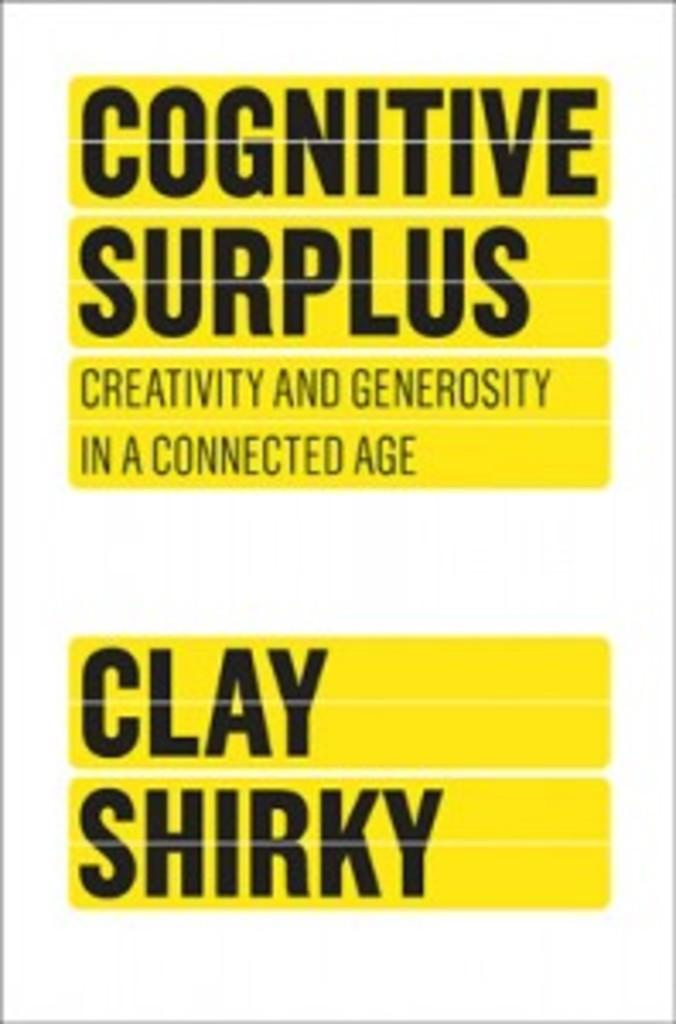<image>
Relay a brief, clear account of the picture shown. Cognitive Surplus is a book by the author Clay Shirky. 